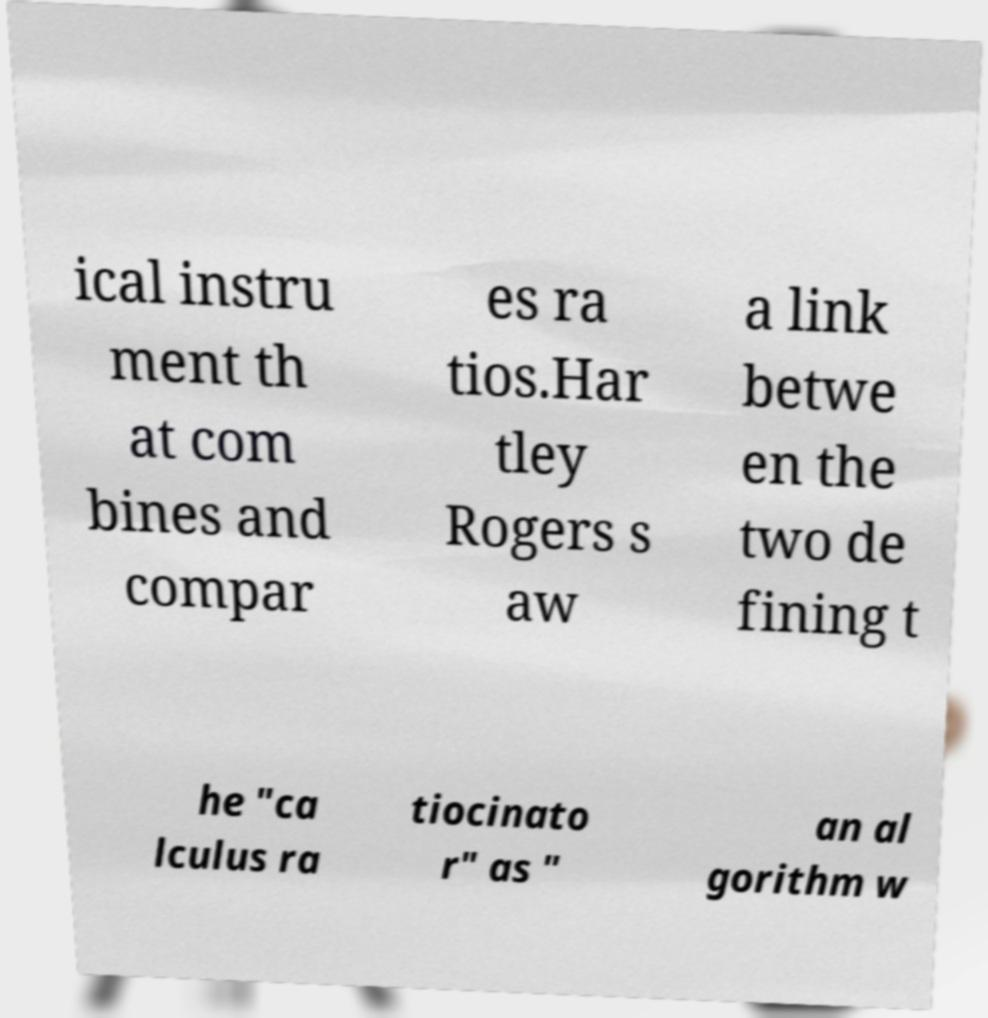What messages or text are displayed in this image? I need them in a readable, typed format. ical instru ment th at com bines and compar es ra tios.Har tley Rogers s aw a link betwe en the two de fining t he "ca lculus ra tiocinato r" as " an al gorithm w 